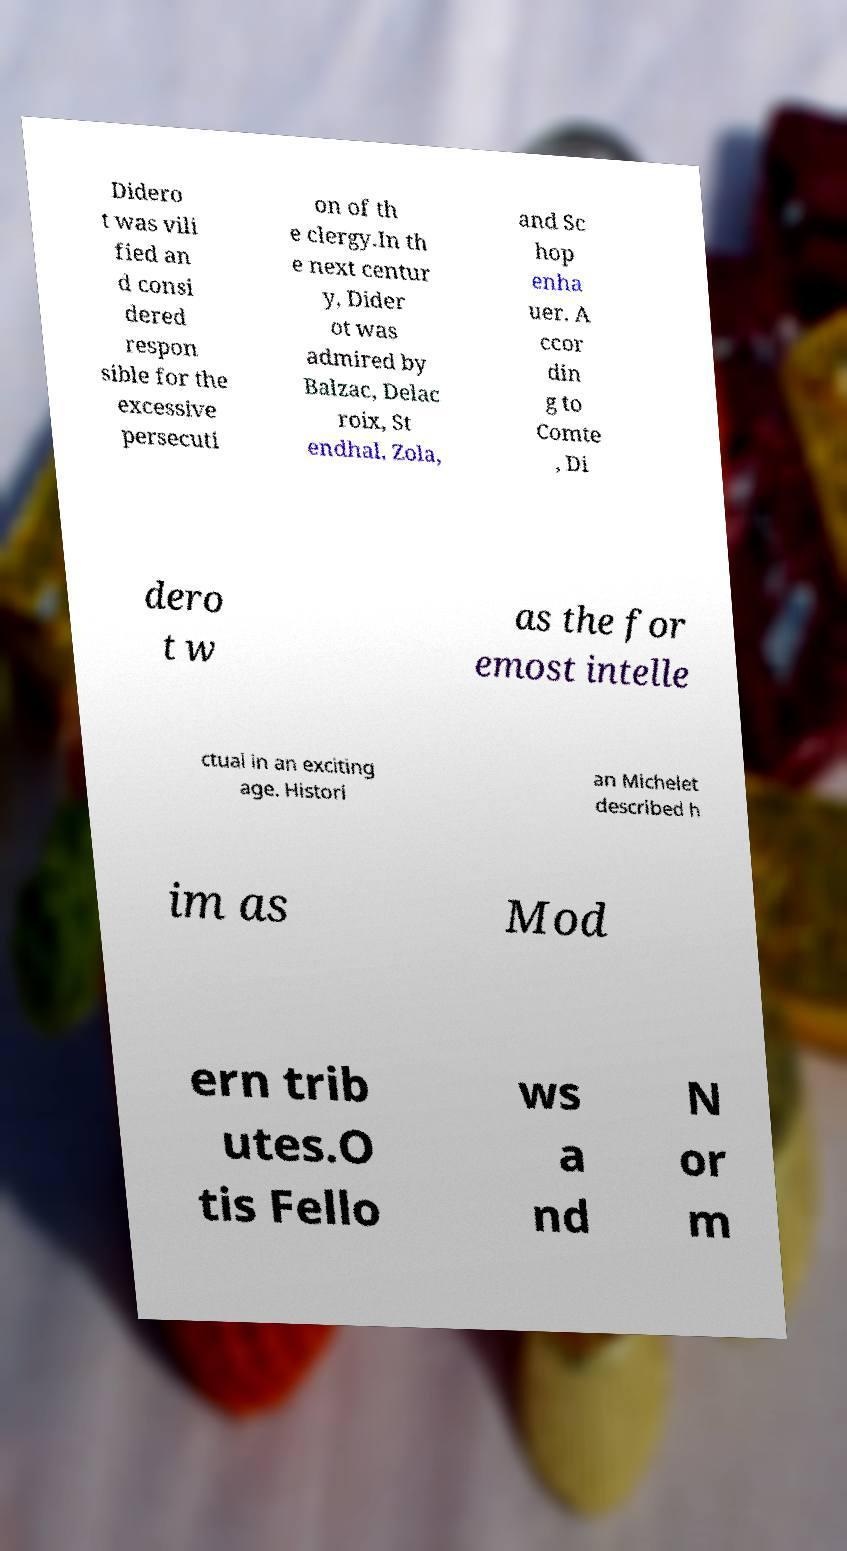Please identify and transcribe the text found in this image. Didero t was vili fied an d consi dered respon sible for the excessive persecuti on of th e clergy.In th e next centur y, Dider ot was admired by Balzac, Delac roix, St endhal, Zola, and Sc hop enha uer. A ccor din g to Comte , Di dero t w as the for emost intelle ctual in an exciting age. Histori an Michelet described h im as Mod ern trib utes.O tis Fello ws a nd N or m 